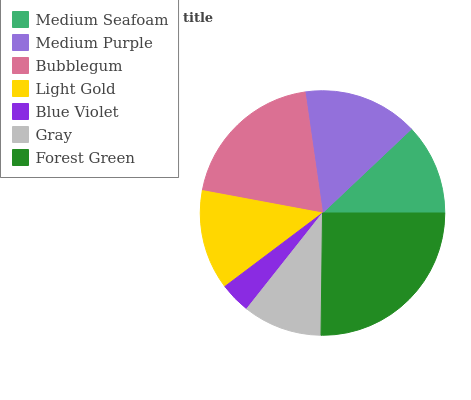Is Blue Violet the minimum?
Answer yes or no. Yes. Is Forest Green the maximum?
Answer yes or no. Yes. Is Medium Purple the minimum?
Answer yes or no. No. Is Medium Purple the maximum?
Answer yes or no. No. Is Medium Purple greater than Medium Seafoam?
Answer yes or no. Yes. Is Medium Seafoam less than Medium Purple?
Answer yes or no. Yes. Is Medium Seafoam greater than Medium Purple?
Answer yes or no. No. Is Medium Purple less than Medium Seafoam?
Answer yes or no. No. Is Light Gold the high median?
Answer yes or no. Yes. Is Light Gold the low median?
Answer yes or no. Yes. Is Forest Green the high median?
Answer yes or no. No. Is Medium Seafoam the low median?
Answer yes or no. No. 